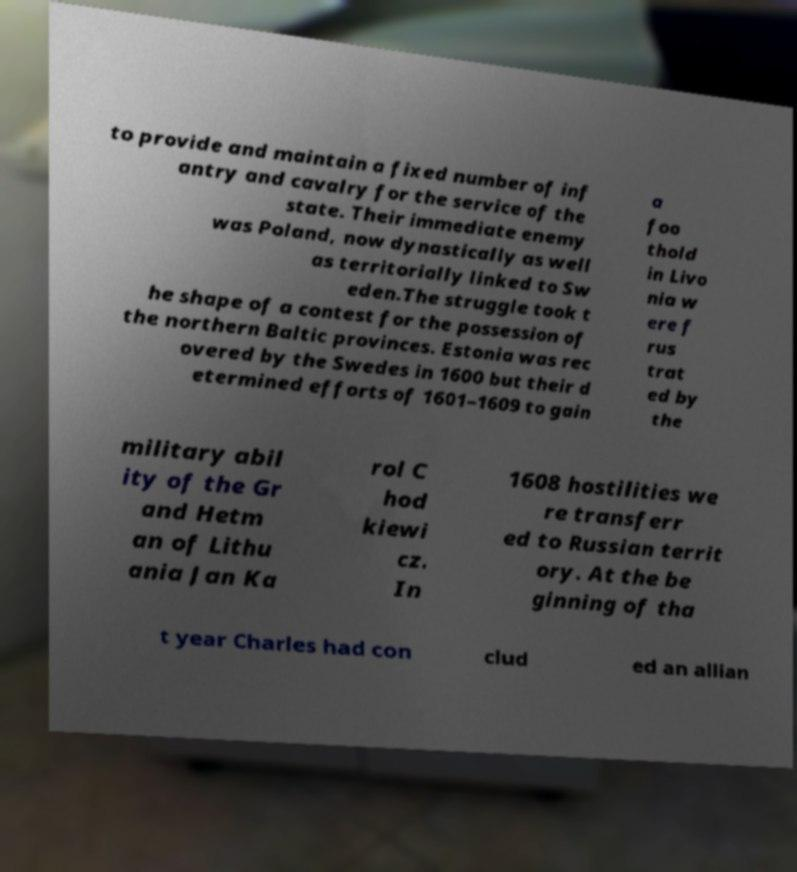I need the written content from this picture converted into text. Can you do that? to provide and maintain a fixed number of inf antry and cavalry for the service of the state. Their immediate enemy was Poland, now dynastically as well as territorially linked to Sw eden.The struggle took t he shape of a contest for the possession of the northern Baltic provinces. Estonia was rec overed by the Swedes in 1600 but their d etermined efforts of 1601–1609 to gain a foo thold in Livo nia w ere f rus trat ed by the military abil ity of the Gr and Hetm an of Lithu ania Jan Ka rol C hod kiewi cz. In 1608 hostilities we re transferr ed to Russian territ ory. At the be ginning of tha t year Charles had con clud ed an allian 